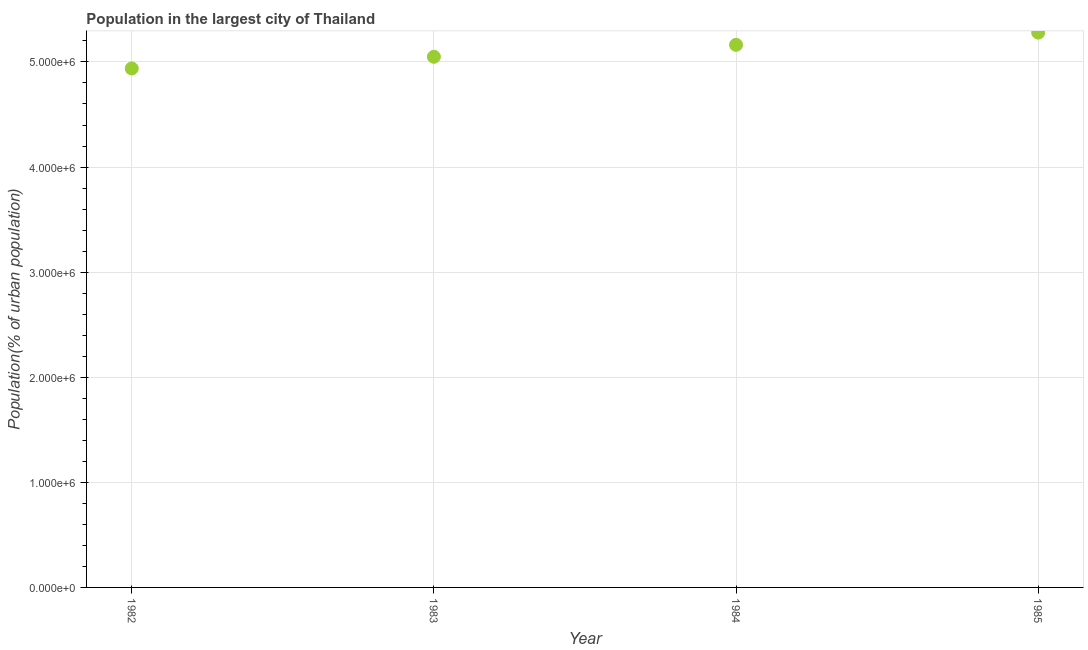What is the population in largest city in 1984?
Your response must be concise. 5.16e+06. Across all years, what is the maximum population in largest city?
Your answer should be very brief. 5.28e+06. Across all years, what is the minimum population in largest city?
Provide a short and direct response. 4.94e+06. In which year was the population in largest city minimum?
Give a very brief answer. 1982. What is the sum of the population in largest city?
Offer a very short reply. 2.04e+07. What is the difference between the population in largest city in 1982 and 1985?
Make the answer very short. -3.41e+05. What is the average population in largest city per year?
Make the answer very short. 5.11e+06. What is the median population in largest city?
Offer a very short reply. 5.11e+06. In how many years, is the population in largest city greater than 2200000 %?
Provide a short and direct response. 4. What is the ratio of the population in largest city in 1982 to that in 1983?
Your answer should be compact. 0.98. Is the population in largest city in 1983 less than that in 1985?
Provide a short and direct response. Yes. Is the difference between the population in largest city in 1982 and 1984 greater than the difference between any two years?
Provide a succinct answer. No. What is the difference between the highest and the second highest population in largest city?
Provide a short and direct response. 1.16e+05. What is the difference between the highest and the lowest population in largest city?
Your response must be concise. 3.41e+05. In how many years, is the population in largest city greater than the average population in largest city taken over all years?
Provide a short and direct response. 2. How many years are there in the graph?
Ensure brevity in your answer.  4. What is the difference between two consecutive major ticks on the Y-axis?
Your response must be concise. 1.00e+06. Does the graph contain any zero values?
Your answer should be compact. No. What is the title of the graph?
Give a very brief answer. Population in the largest city of Thailand. What is the label or title of the Y-axis?
Provide a succinct answer. Population(% of urban population). What is the Population(% of urban population) in 1982?
Make the answer very short. 4.94e+06. What is the Population(% of urban population) in 1983?
Ensure brevity in your answer.  5.05e+06. What is the Population(% of urban population) in 1984?
Make the answer very short. 5.16e+06. What is the Population(% of urban population) in 1985?
Provide a short and direct response. 5.28e+06. What is the difference between the Population(% of urban population) in 1982 and 1983?
Your response must be concise. -1.11e+05. What is the difference between the Population(% of urban population) in 1982 and 1984?
Provide a short and direct response. -2.25e+05. What is the difference between the Population(% of urban population) in 1982 and 1985?
Your answer should be very brief. -3.41e+05. What is the difference between the Population(% of urban population) in 1983 and 1984?
Provide a succinct answer. -1.14e+05. What is the difference between the Population(% of urban population) in 1983 and 1985?
Give a very brief answer. -2.30e+05. What is the difference between the Population(% of urban population) in 1984 and 1985?
Provide a short and direct response. -1.16e+05. What is the ratio of the Population(% of urban population) in 1982 to that in 1984?
Provide a short and direct response. 0.96. What is the ratio of the Population(% of urban population) in 1982 to that in 1985?
Ensure brevity in your answer.  0.94. What is the ratio of the Population(% of urban population) in 1983 to that in 1985?
Your response must be concise. 0.96. What is the ratio of the Population(% of urban population) in 1984 to that in 1985?
Your response must be concise. 0.98. 